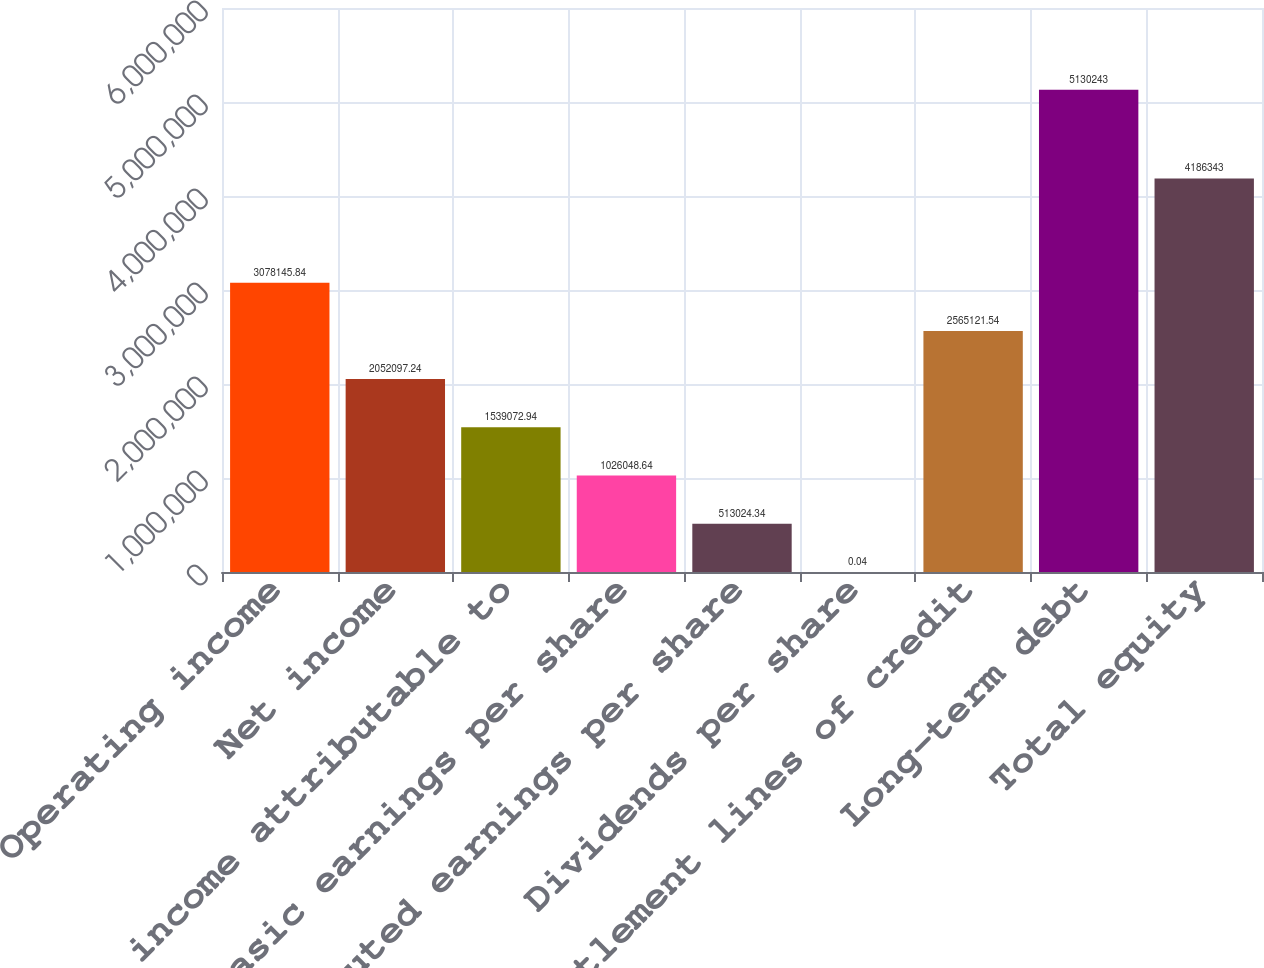Convert chart to OTSL. <chart><loc_0><loc_0><loc_500><loc_500><bar_chart><fcel>Operating income<fcel>Net income<fcel>Net income attributable to<fcel>Basic earnings per share<fcel>Diluted earnings per share<fcel>Dividends per share<fcel>Settlement lines of credit<fcel>Long-term debt<fcel>Total equity<nl><fcel>3.07815e+06<fcel>2.0521e+06<fcel>1.53907e+06<fcel>1.02605e+06<fcel>513024<fcel>0.04<fcel>2.56512e+06<fcel>5.13024e+06<fcel>4.18634e+06<nl></chart> 